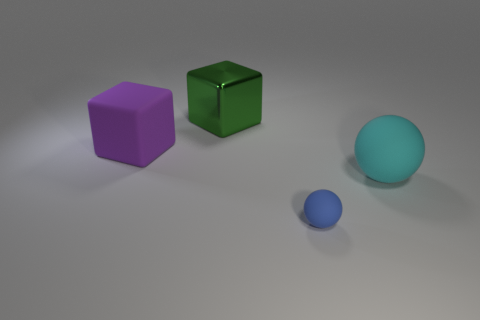Add 4 cyan rubber objects. How many objects exist? 8 Subtract 0 green spheres. How many objects are left? 4 Subtract all small blue things. Subtract all cyan things. How many objects are left? 2 Add 3 large things. How many large things are left? 6 Add 3 blue rubber cylinders. How many blue rubber cylinders exist? 3 